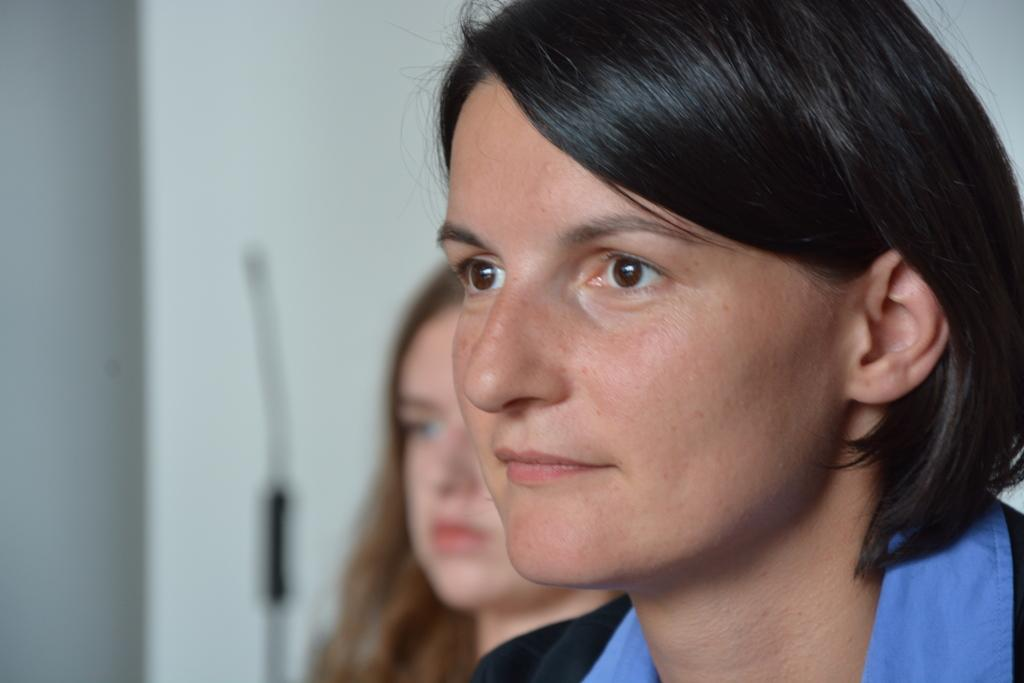How many people are present in the image? There are girls in the image. What type of leaf is being touched by the deer in the image? There is no leaf or deer present in the image; it only features girls. 